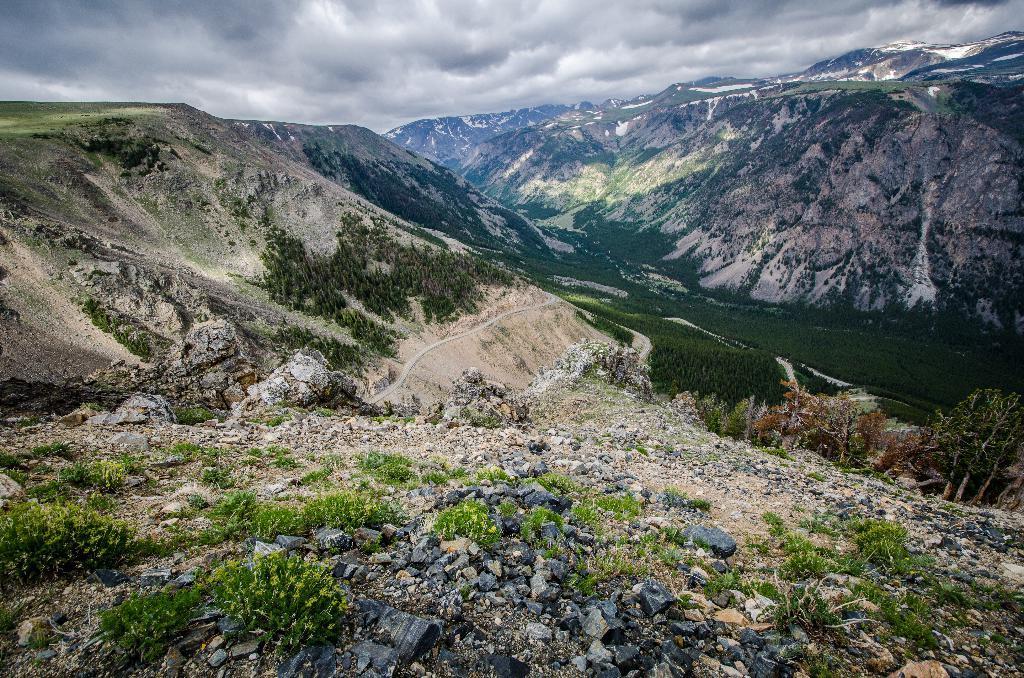In one or two sentences, can you explain what this image depicts? On the ground there are rocks and plants. In the back there are hills. Also there is a road on the hill. In the background there is sky with clouds. 